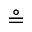<formula> <loc_0><loc_0><loc_500><loc_500>\circ e q</formula> 